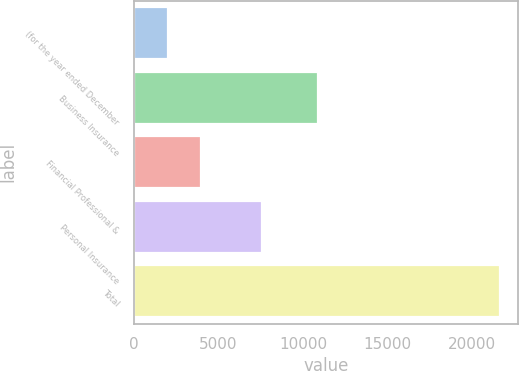Convert chart. <chart><loc_0><loc_0><loc_500><loc_500><bar_chart><fcel>(for the year ended December<fcel>Business Insurance<fcel>Financial Professional &<fcel>Personal Insurance<fcel>Total<nl><fcel>2010<fcel>10857<fcel>3972.5<fcel>7567<fcel>21635<nl></chart> 